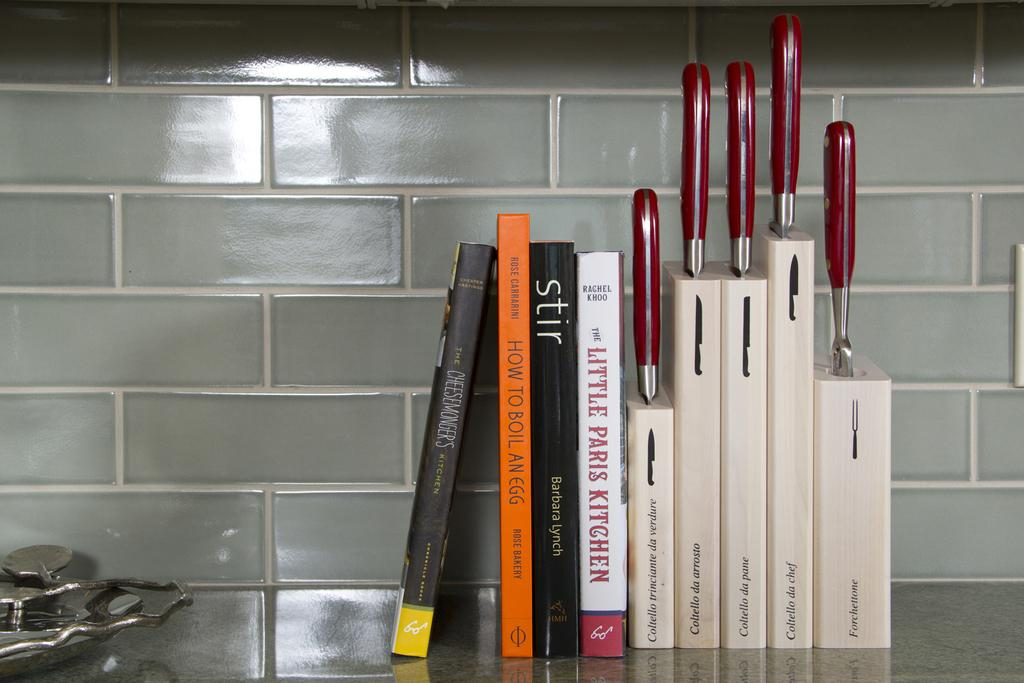<image>
Create a compact narrative representing the image presented. A kitchen counter with cookbooks and knives, one book says Little Paris Kitchen. 